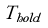Convert formula to latex. <formula><loc_0><loc_0><loc_500><loc_500>T _ { h o l d }</formula> 